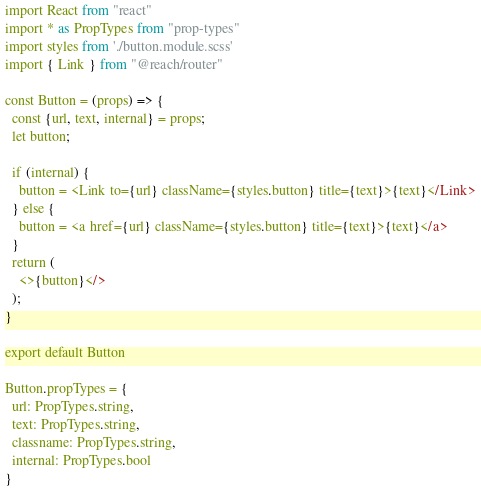Convert code to text. <code><loc_0><loc_0><loc_500><loc_500><_JavaScript_>import React from "react"
import * as PropTypes from "prop-types"
import styles from './button.module.scss'
import { Link } from "@reach/router"

const Button = (props) => {
  const {url, text, internal} = props;
  let button;

  if (internal) {
    button = <Link to={url} className={styles.button} title={text}>{text}</Link>
  } else {
    button = <a href={url} className={styles.button} title={text}>{text}</a>
  }
  return (
    <>{button}</>
  );
}

export default Button

Button.propTypes = {
  url: PropTypes.string,
  text: PropTypes.string,
  classname: PropTypes.string,
  internal: PropTypes.bool
}
</code> 